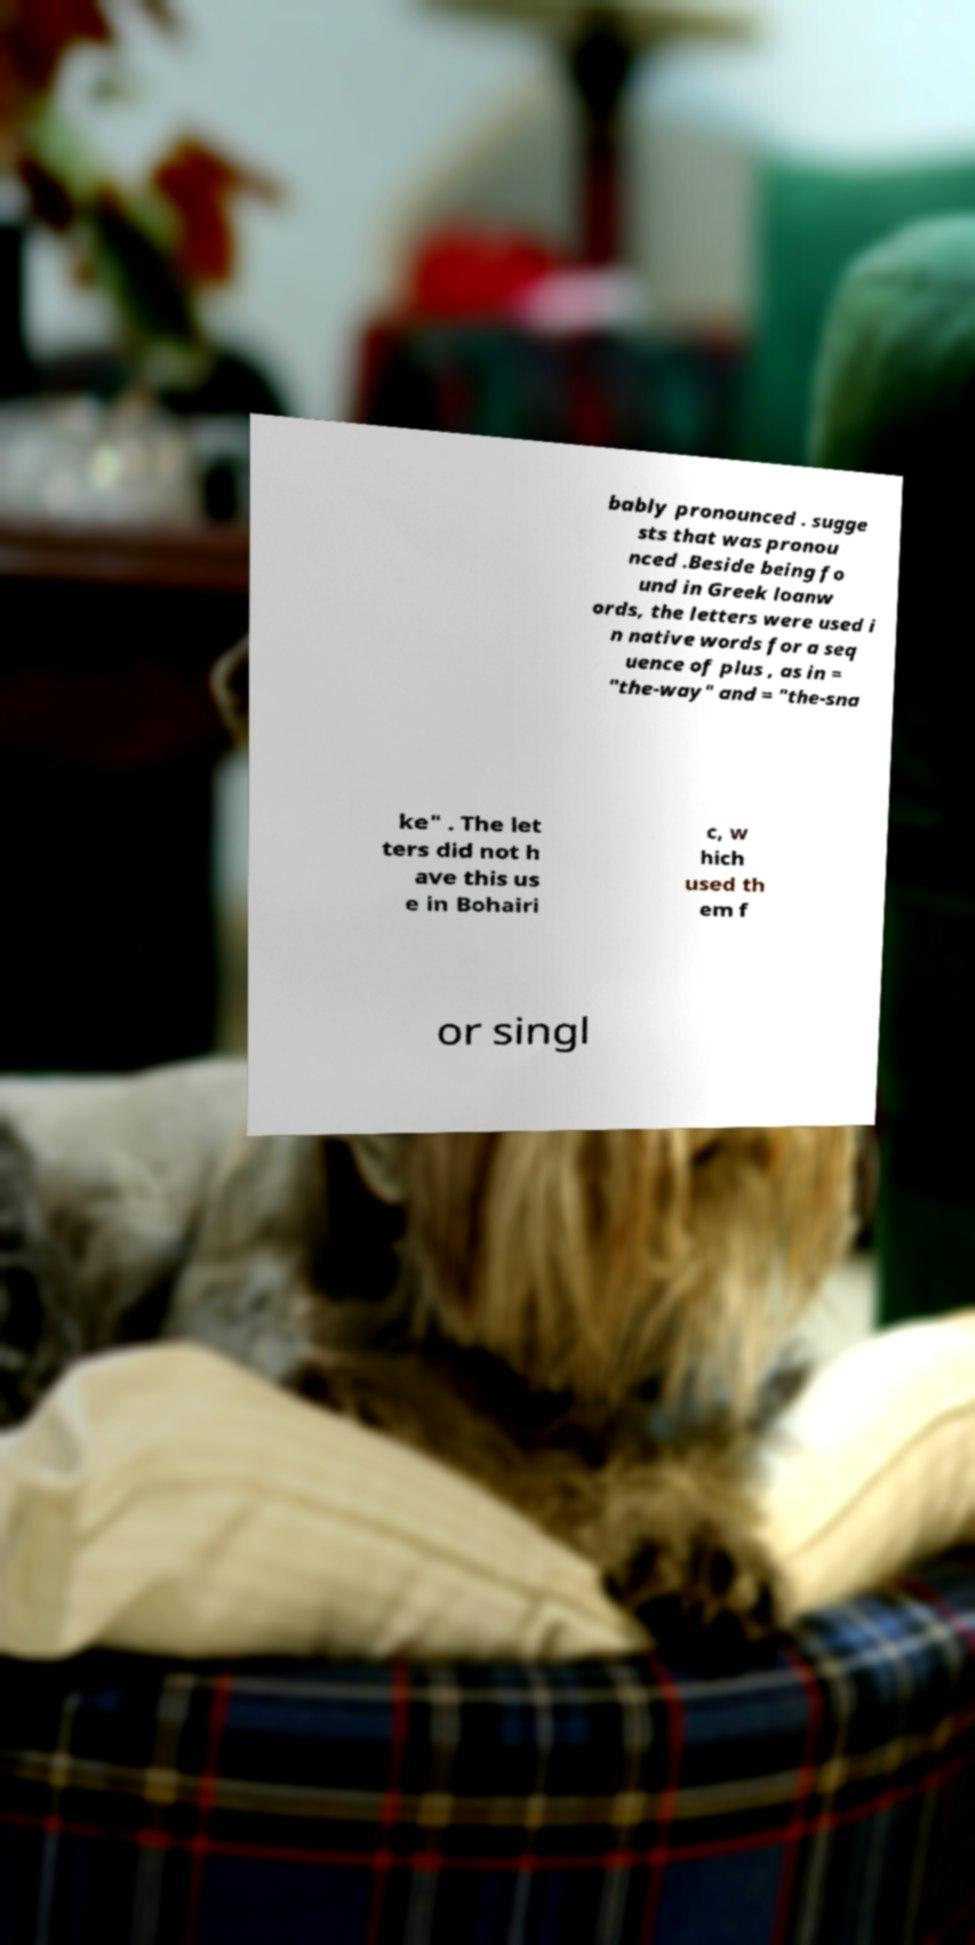I need the written content from this picture converted into text. Can you do that? bably pronounced . sugge sts that was pronou nced .Beside being fo und in Greek loanw ords, the letters were used i n native words for a seq uence of plus , as in = "the-way" and = "the-sna ke" . The let ters did not h ave this us e in Bohairi c, w hich used th em f or singl 